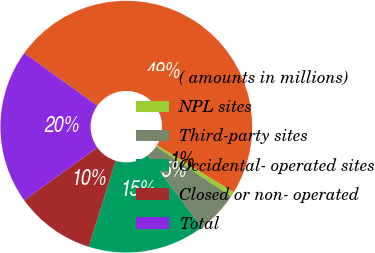Convert chart. <chart><loc_0><loc_0><loc_500><loc_500><pie_chart><fcel>( amounts in millions)<fcel>NPL sites<fcel>Third-party sites<fcel>Occidental- operated sites<fcel>Closed or non- operated<fcel>Total<nl><fcel>48.79%<fcel>0.61%<fcel>5.42%<fcel>15.06%<fcel>10.24%<fcel>19.88%<nl></chart> 